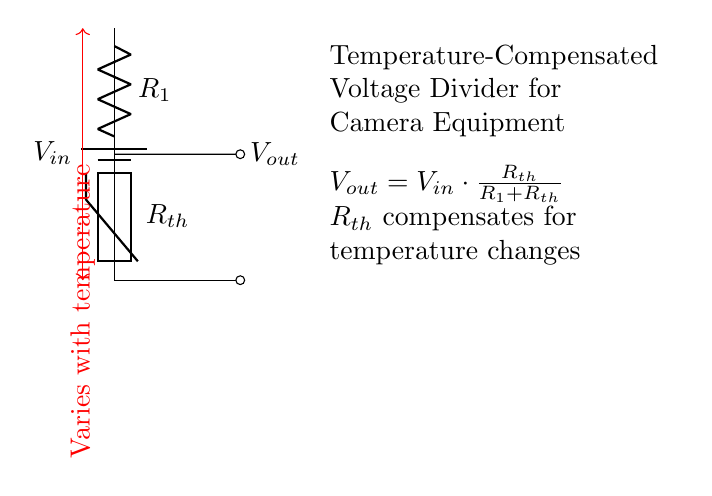What type of circuit is represented in the diagram? The diagram illustrates a voltage divider circuit, which is used to produce a specific output voltage that is a fraction of the input voltage. The components arranged in series form a voltage divider specifically due to the presence of resistors in series.
Answer: Voltage divider What component varies with temperature? The thermistor, labeled as Rth in the circuit, changes its resistance based on temperature, hence compensating for temperature variations. It is specifically designed to react to changes in ambient temperature.
Answer: Rth What is the relationship of the output voltage to the input voltage? The output voltage is directly determined by the formula provided in the circuit: Vout = Vin multiplied by the ratio of Rth over the total resistance (R1 + Rth). This indicates that output voltage is a fraction of the input voltage based on resistances.
Answer: Vout = Vin * Rth / (R1 + Rth) What specific role does Rth play in this circuit? Rth functions as a temperature compensator in the voltage divider. Its resistance changes with temperature, allowing the output voltage to remain stable despite environmental temperature variations.
Answer: Temperature compensation What is the formula for the output voltage in this circuit? The circuit provides the formula Vout = Vin * Rth / (R1 + Rth), which describes how to calculate the output voltage based on the values of Vin, Rth, and R1. The output is dependent on the configuration of these resistances.
Answer: Vout = Vin * Rth / (R1 + Rth) How many components are used in this voltage divider circuit? The circuit includes three main components: a voltage source (V_in), a resistor (R_1), and a thermistor (R_th). These components work together to form the complete voltage divider circuit for maintaining stable output.
Answer: Three components 